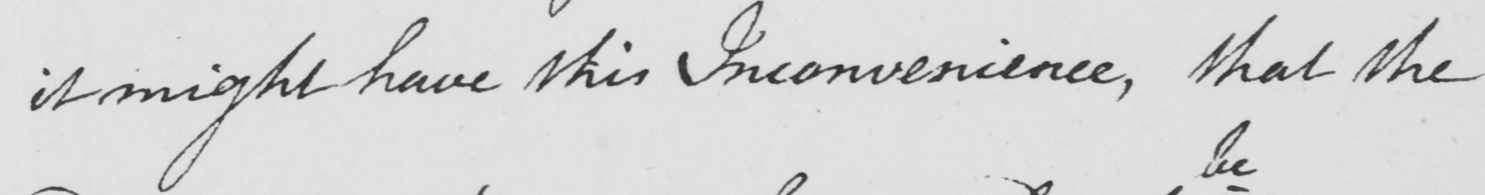Can you tell me what this handwritten text says? it might have this Inconvenience, that the 